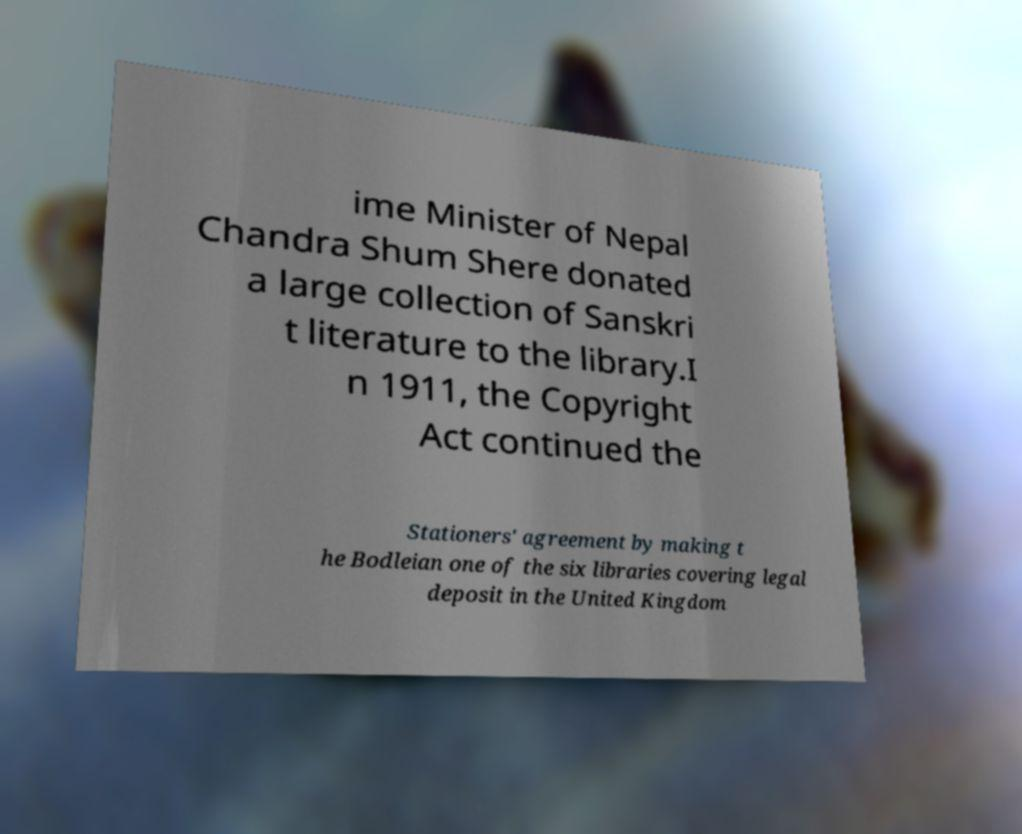What messages or text are displayed in this image? I need them in a readable, typed format. ime Minister of Nepal Chandra Shum Shere donated a large collection of Sanskri t literature to the library.I n 1911, the Copyright Act continued the Stationers' agreement by making t he Bodleian one of the six libraries covering legal deposit in the United Kingdom 